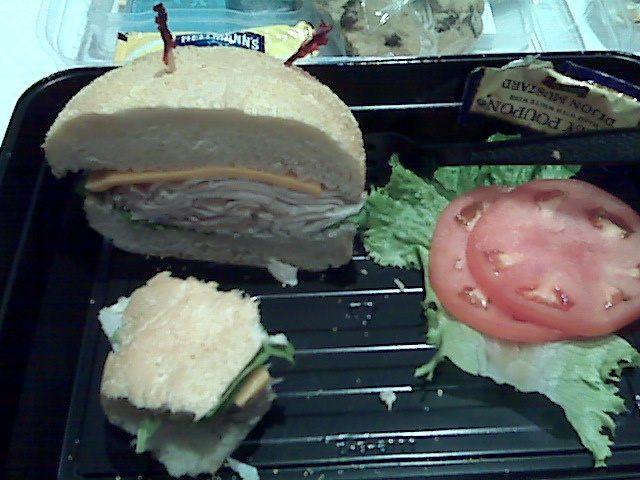Describe the objects in this image and their specific colors. I can see sandwich in lightblue, gray, beige, and black tones, sandwich in lightblue, beige, darkgray, and black tones, and fork in lightblue, black, darkgreen, and gray tones in this image. 